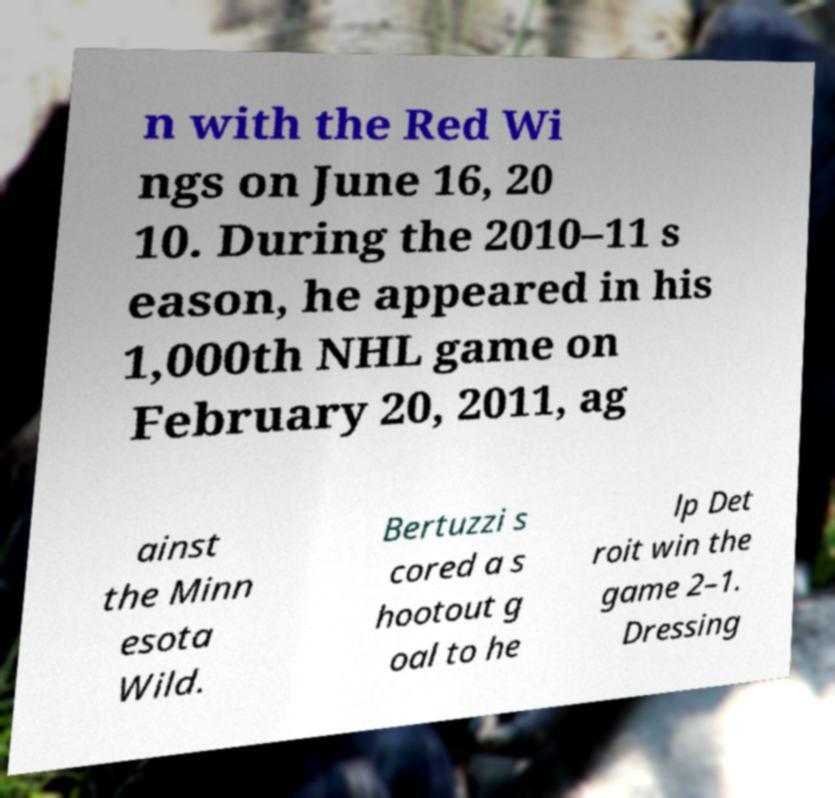There's text embedded in this image that I need extracted. Can you transcribe it verbatim? n with the Red Wi ngs on June 16, 20 10. During the 2010–11 s eason, he appeared in his 1,000th NHL game on February 20, 2011, ag ainst the Minn esota Wild. Bertuzzi s cored a s hootout g oal to he lp Det roit win the game 2–1. Dressing 